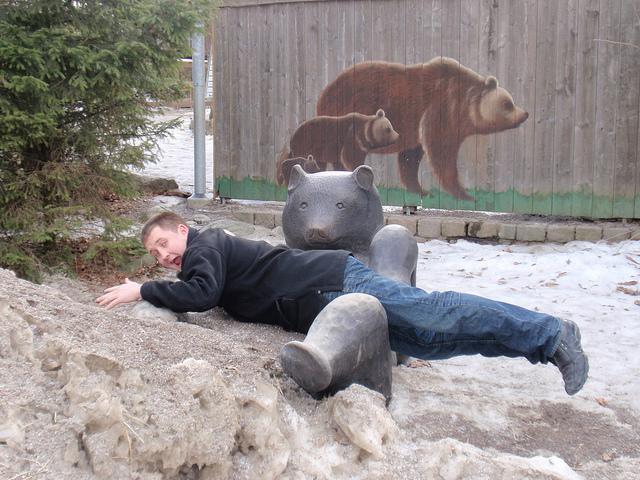Is the person screaming?
Keep it brief. Yes. Are those real bears in the picture?
Quick response, please. No. What animal is pictured?
Keep it brief. Bear. 